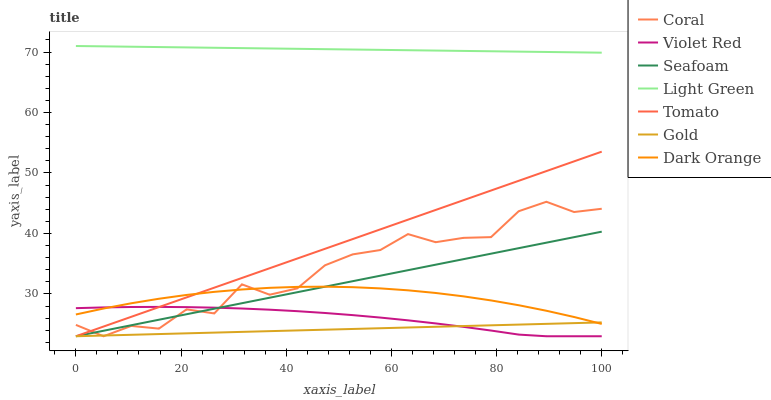Does Gold have the minimum area under the curve?
Answer yes or no. Yes. Does Light Green have the maximum area under the curve?
Answer yes or no. Yes. Does Dark Orange have the minimum area under the curve?
Answer yes or no. No. Does Dark Orange have the maximum area under the curve?
Answer yes or no. No. Is Gold the smoothest?
Answer yes or no. Yes. Is Coral the roughest?
Answer yes or no. Yes. Is Dark Orange the smoothest?
Answer yes or no. No. Is Dark Orange the roughest?
Answer yes or no. No. Does Dark Orange have the lowest value?
Answer yes or no. No. Does Light Green have the highest value?
Answer yes or no. Yes. Does Dark Orange have the highest value?
Answer yes or no. No. Is Tomato less than Light Green?
Answer yes or no. Yes. Is Light Green greater than Tomato?
Answer yes or no. Yes. Does Gold intersect Dark Orange?
Answer yes or no. Yes. Is Gold less than Dark Orange?
Answer yes or no. No. Is Gold greater than Dark Orange?
Answer yes or no. No. Does Tomato intersect Light Green?
Answer yes or no. No. 